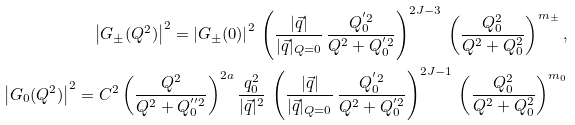Convert formula to latex. <formula><loc_0><loc_0><loc_500><loc_500>\left | G _ { \pm } ( Q ^ { 2 } ) \right | ^ { 2 } = \left | G _ { \pm } ( 0 ) \right | ^ { 2 } \, \left ( \frac { | \vec { q } | } { | \vec { q } | _ { Q = 0 } } \, \frac { Q _ { 0 } ^ { ^ { \prime } 2 } } { Q ^ { 2 } + Q _ { 0 } ^ { ^ { \prime } 2 } } \right ) ^ { 2 J - 3 } \, \left ( \frac { Q _ { 0 } ^ { 2 } } { Q ^ { 2 } + Q _ { 0 } ^ { 2 } } \right ) ^ { m _ { \pm } } , \\ \left | G _ { 0 } ( Q ^ { 2 } ) \right | ^ { 2 } = C ^ { 2 } \left ( \frac { Q ^ { 2 } } { Q ^ { 2 } + Q _ { 0 } ^ { ^ { \prime \prime } 2 } } \right ) ^ { 2 a } \frac { q _ { 0 } ^ { 2 } } { | \vec { q } | ^ { 2 } } \, \left ( \frac { | \vec { q } | } { | \vec { q } | _ { Q = 0 } } \, \frac { Q _ { 0 } ^ { ^ { \prime } 2 } } { Q ^ { 2 } + Q _ { 0 } ^ { ^ { \prime } 2 } } \right ) ^ { 2 J - 1 } \, \left ( \frac { Q _ { 0 } ^ { 2 } } { Q ^ { 2 } + Q _ { 0 } ^ { 2 } } \right ) ^ { m _ { 0 } }</formula> 